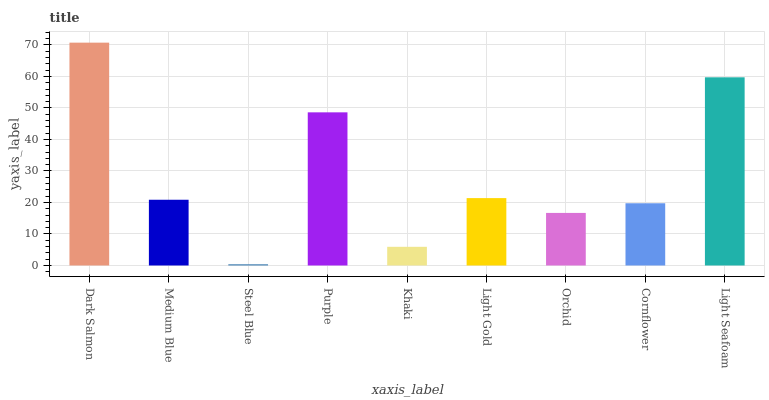Is Steel Blue the minimum?
Answer yes or no. Yes. Is Dark Salmon the maximum?
Answer yes or no. Yes. Is Medium Blue the minimum?
Answer yes or no. No. Is Medium Blue the maximum?
Answer yes or no. No. Is Dark Salmon greater than Medium Blue?
Answer yes or no. Yes. Is Medium Blue less than Dark Salmon?
Answer yes or no. Yes. Is Medium Blue greater than Dark Salmon?
Answer yes or no. No. Is Dark Salmon less than Medium Blue?
Answer yes or no. No. Is Medium Blue the high median?
Answer yes or no. Yes. Is Medium Blue the low median?
Answer yes or no. Yes. Is Light Gold the high median?
Answer yes or no. No. Is Light Seafoam the low median?
Answer yes or no. No. 